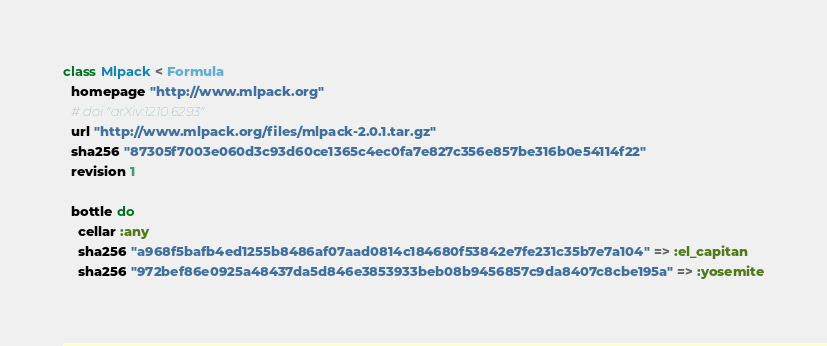<code> <loc_0><loc_0><loc_500><loc_500><_Ruby_>class Mlpack < Formula
  homepage "http://www.mlpack.org"
  # doi "arXiv:1210.6293"
  url "http://www.mlpack.org/files/mlpack-2.0.1.tar.gz"
  sha256 "87305f7003e060d3c93d60ce1365c4ec0fa7e827c356e857be316b0e54114f22"
  revision 1

  bottle do
    cellar :any
    sha256 "a968f5bafb4ed1255b8486af07aad0814c184680f53842e7fe231c35b7e7a104" => :el_capitan
    sha256 "972bef86e0925a48437da5d846e3853933beb08b9456857c9da8407c8cbe195a" => :yosemite</code> 